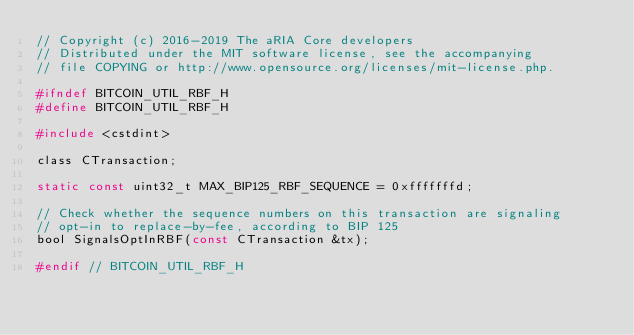Convert code to text. <code><loc_0><loc_0><loc_500><loc_500><_C_>// Copyright (c) 2016-2019 The aRIA Core developers
// Distributed under the MIT software license, see the accompanying
// file COPYING or http://www.opensource.org/licenses/mit-license.php.

#ifndef BITCOIN_UTIL_RBF_H
#define BITCOIN_UTIL_RBF_H

#include <cstdint>

class CTransaction;

static const uint32_t MAX_BIP125_RBF_SEQUENCE = 0xfffffffd;

// Check whether the sequence numbers on this transaction are signaling
// opt-in to replace-by-fee, according to BIP 125
bool SignalsOptInRBF(const CTransaction &tx);

#endif // BITCOIN_UTIL_RBF_H
</code> 